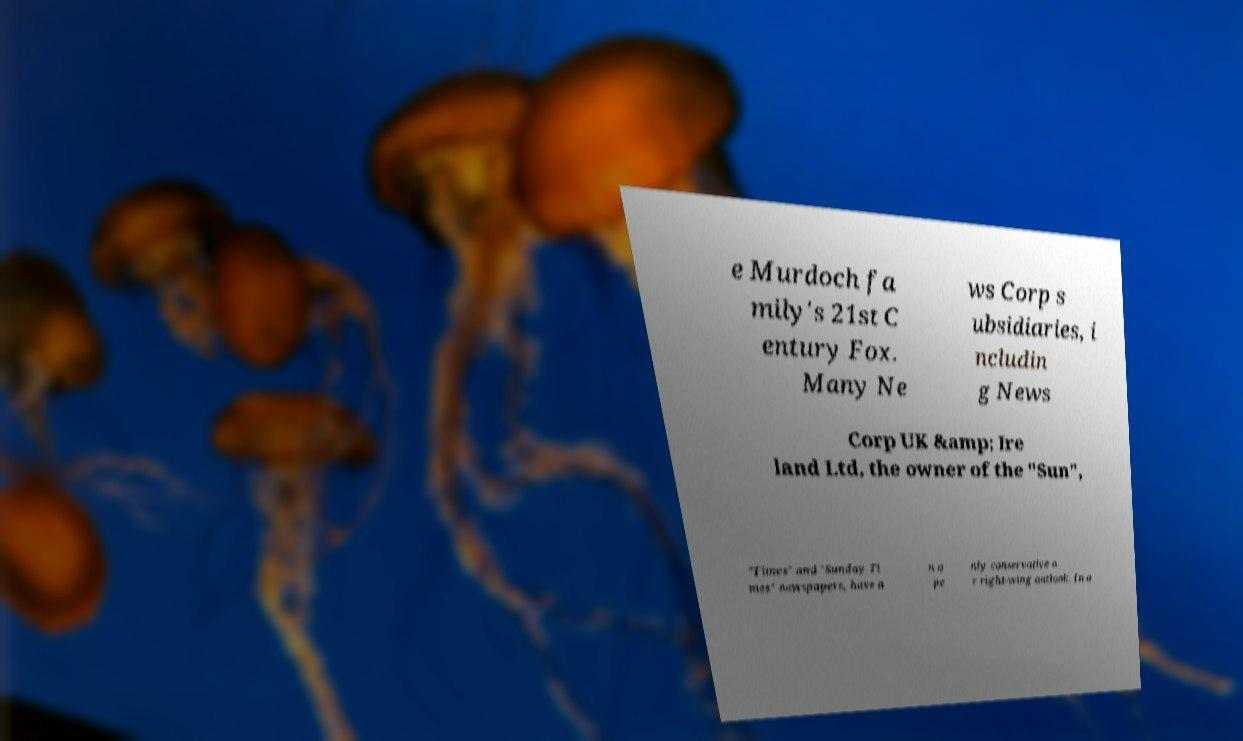There's text embedded in this image that I need extracted. Can you transcribe it verbatim? e Murdoch fa mily's 21st C entury Fox. Many Ne ws Corp s ubsidiaries, i ncludin g News Corp UK &amp; Ire land Ltd, the owner of the "Sun", "Times" and "Sunday Ti mes" newspapers, have a n o pe nly conservative o r right-wing outlook. In a 